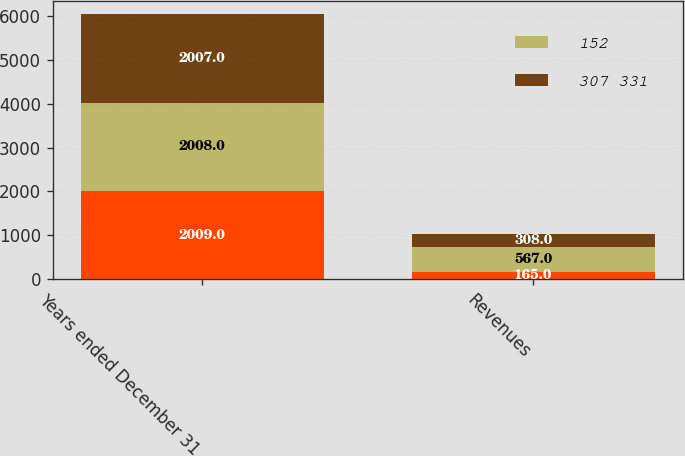Convert chart to OTSL. <chart><loc_0><loc_0><loc_500><loc_500><stacked_bar_chart><ecel><fcel>Years ended December 31<fcel>Revenues<nl><fcel>nan<fcel>2009<fcel>165<nl><fcel>152<fcel>2008<fcel>567<nl><fcel>307 331<fcel>2007<fcel>308<nl></chart> 